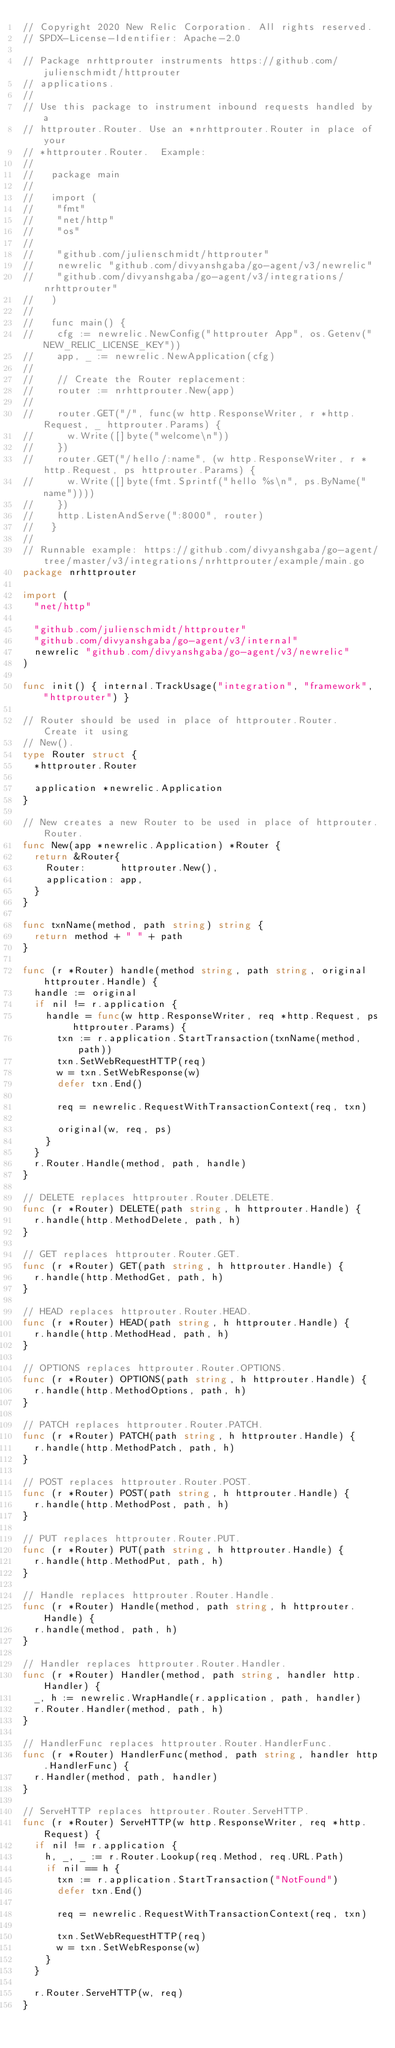<code> <loc_0><loc_0><loc_500><loc_500><_Go_>// Copyright 2020 New Relic Corporation. All rights reserved.
// SPDX-License-Identifier: Apache-2.0

// Package nrhttprouter instruments https://github.com/julienschmidt/httprouter
// applications.
//
// Use this package to instrument inbound requests handled by a
// httprouter.Router. Use an *nrhttprouter.Router in place of your
// *httprouter.Router.  Example:
//
//   package main
//
//   import (
//   	"fmt"
//   	"net/http"
//   	"os"
//
//   	"github.com/julienschmidt/httprouter"
//   	newrelic "github.com/divyanshgaba/go-agent/v3/newrelic"
//   	"github.com/divyanshgaba/go-agent/v3/integrations/nrhttprouter"
//   )
//
//   func main() {
//   	cfg := newrelic.NewConfig("httprouter App", os.Getenv("NEW_RELIC_LICENSE_KEY"))
//   	app, _ := newrelic.NewApplication(cfg)
//
//   	// Create the Router replacement:
//   	router := nrhttprouter.New(app)
//
//   	router.GET("/", func(w http.ResponseWriter, r *http.Request, _ httprouter.Params) {
//   		w.Write([]byte("welcome\n"))
//   	})
//   	router.GET("/hello/:name", (w http.ResponseWriter, r *http.Request, ps httprouter.Params) {
//   		w.Write([]byte(fmt.Sprintf("hello %s\n", ps.ByName("name"))))
//   	})
//   	http.ListenAndServe(":8000", router)
//   }
//
// Runnable example: https://github.com/divyanshgaba/go-agent/tree/master/v3/integrations/nrhttprouter/example/main.go
package nrhttprouter

import (
	"net/http"

	"github.com/julienschmidt/httprouter"
	"github.com/divyanshgaba/go-agent/v3/internal"
	newrelic "github.com/divyanshgaba/go-agent/v3/newrelic"
)

func init() { internal.TrackUsage("integration", "framework", "httprouter") }

// Router should be used in place of httprouter.Router.  Create it using
// New().
type Router struct {
	*httprouter.Router

	application *newrelic.Application
}

// New creates a new Router to be used in place of httprouter.Router.
func New(app *newrelic.Application) *Router {
	return &Router{
		Router:      httprouter.New(),
		application: app,
	}
}

func txnName(method, path string) string {
	return method + " " + path
}

func (r *Router) handle(method string, path string, original httprouter.Handle) {
	handle := original
	if nil != r.application {
		handle = func(w http.ResponseWriter, req *http.Request, ps httprouter.Params) {
			txn := r.application.StartTransaction(txnName(method, path))
			txn.SetWebRequestHTTP(req)
			w = txn.SetWebResponse(w)
			defer txn.End()

			req = newrelic.RequestWithTransactionContext(req, txn)

			original(w, req, ps)
		}
	}
	r.Router.Handle(method, path, handle)
}

// DELETE replaces httprouter.Router.DELETE.
func (r *Router) DELETE(path string, h httprouter.Handle) {
	r.handle(http.MethodDelete, path, h)
}

// GET replaces httprouter.Router.GET.
func (r *Router) GET(path string, h httprouter.Handle) {
	r.handle(http.MethodGet, path, h)
}

// HEAD replaces httprouter.Router.HEAD.
func (r *Router) HEAD(path string, h httprouter.Handle) {
	r.handle(http.MethodHead, path, h)
}

// OPTIONS replaces httprouter.Router.OPTIONS.
func (r *Router) OPTIONS(path string, h httprouter.Handle) {
	r.handle(http.MethodOptions, path, h)
}

// PATCH replaces httprouter.Router.PATCH.
func (r *Router) PATCH(path string, h httprouter.Handle) {
	r.handle(http.MethodPatch, path, h)
}

// POST replaces httprouter.Router.POST.
func (r *Router) POST(path string, h httprouter.Handle) {
	r.handle(http.MethodPost, path, h)
}

// PUT replaces httprouter.Router.PUT.
func (r *Router) PUT(path string, h httprouter.Handle) {
	r.handle(http.MethodPut, path, h)
}

// Handle replaces httprouter.Router.Handle.
func (r *Router) Handle(method, path string, h httprouter.Handle) {
	r.handle(method, path, h)
}

// Handler replaces httprouter.Router.Handler.
func (r *Router) Handler(method, path string, handler http.Handler) {
	_, h := newrelic.WrapHandle(r.application, path, handler)
	r.Router.Handler(method, path, h)
}

// HandlerFunc replaces httprouter.Router.HandlerFunc.
func (r *Router) HandlerFunc(method, path string, handler http.HandlerFunc) {
	r.Handler(method, path, handler)
}

// ServeHTTP replaces httprouter.Router.ServeHTTP.
func (r *Router) ServeHTTP(w http.ResponseWriter, req *http.Request) {
	if nil != r.application {
		h, _, _ := r.Router.Lookup(req.Method, req.URL.Path)
		if nil == h {
			txn := r.application.StartTransaction("NotFound")
			defer txn.End()

			req = newrelic.RequestWithTransactionContext(req, txn)

			txn.SetWebRequestHTTP(req)
			w = txn.SetWebResponse(w)
		}
	}

	r.Router.ServeHTTP(w, req)
}
</code> 